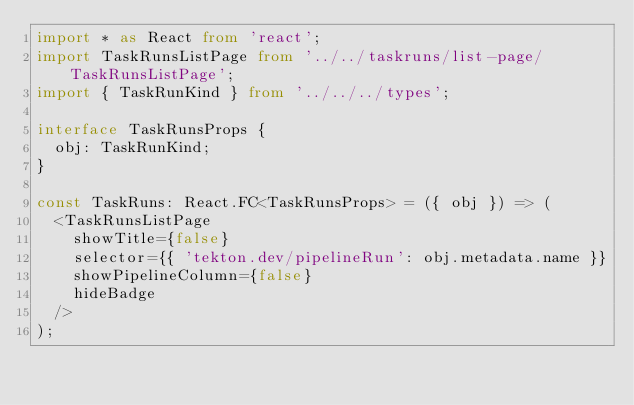<code> <loc_0><loc_0><loc_500><loc_500><_TypeScript_>import * as React from 'react';
import TaskRunsListPage from '../../taskruns/list-page/TaskRunsListPage';
import { TaskRunKind } from '../../../types';

interface TaskRunsProps {
  obj: TaskRunKind;
}

const TaskRuns: React.FC<TaskRunsProps> = ({ obj }) => (
  <TaskRunsListPage
    showTitle={false}
    selector={{ 'tekton.dev/pipelineRun': obj.metadata.name }}
    showPipelineColumn={false}
    hideBadge
  />
);
</code> 